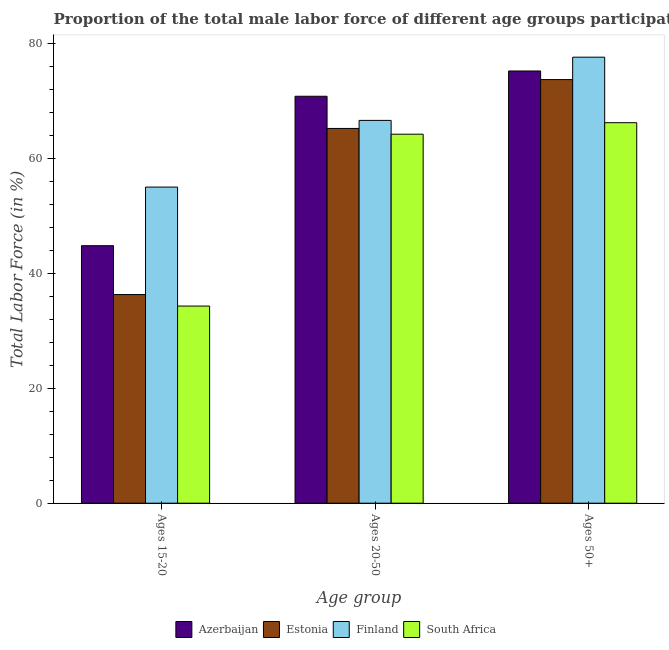How many different coloured bars are there?
Give a very brief answer. 4. How many groups of bars are there?
Make the answer very short. 3. Are the number of bars per tick equal to the number of legend labels?
Your response must be concise. Yes. Are the number of bars on each tick of the X-axis equal?
Keep it short and to the point. Yes. What is the label of the 2nd group of bars from the left?
Offer a terse response. Ages 20-50. What is the percentage of male labor force within the age group 15-20 in Azerbaijan?
Provide a short and direct response. 44.8. Across all countries, what is the maximum percentage of male labor force within the age group 15-20?
Provide a succinct answer. 55. Across all countries, what is the minimum percentage of male labor force above age 50?
Your answer should be very brief. 66.2. In which country was the percentage of male labor force within the age group 20-50 maximum?
Provide a short and direct response. Azerbaijan. In which country was the percentage of male labor force within the age group 20-50 minimum?
Your answer should be very brief. South Africa. What is the total percentage of male labor force within the age group 20-50 in the graph?
Keep it short and to the point. 266.8. What is the difference between the percentage of male labor force within the age group 15-20 in Azerbaijan and that in Estonia?
Give a very brief answer. 8.5. What is the difference between the percentage of male labor force within the age group 20-50 in Finland and the percentage of male labor force above age 50 in Estonia?
Your answer should be very brief. -7.1. What is the average percentage of male labor force within the age group 15-20 per country?
Your answer should be compact. 42.6. What is the difference between the percentage of male labor force within the age group 20-50 and percentage of male labor force within the age group 15-20 in South Africa?
Offer a very short reply. 29.9. In how many countries, is the percentage of male labor force within the age group 15-20 greater than 20 %?
Offer a terse response. 4. What is the ratio of the percentage of male labor force within the age group 20-50 in Estonia to that in South Africa?
Ensure brevity in your answer.  1.02. Is the percentage of male labor force within the age group 20-50 in Finland less than that in Azerbaijan?
Your response must be concise. Yes. What is the difference between the highest and the second highest percentage of male labor force above age 50?
Your response must be concise. 2.4. What is the difference between the highest and the lowest percentage of male labor force above age 50?
Your answer should be compact. 11.4. Is the sum of the percentage of male labor force within the age group 20-50 in Estonia and Azerbaijan greater than the maximum percentage of male labor force within the age group 15-20 across all countries?
Make the answer very short. Yes. What does the 3rd bar from the left in Ages 15-20 represents?
Your answer should be very brief. Finland. What does the 1st bar from the right in Ages 50+ represents?
Provide a short and direct response. South Africa. How many bars are there?
Give a very brief answer. 12. What is the difference between two consecutive major ticks on the Y-axis?
Provide a short and direct response. 20. Are the values on the major ticks of Y-axis written in scientific E-notation?
Provide a succinct answer. No. Does the graph contain grids?
Make the answer very short. No. How many legend labels are there?
Make the answer very short. 4. How are the legend labels stacked?
Keep it short and to the point. Horizontal. What is the title of the graph?
Your response must be concise. Proportion of the total male labor force of different age groups participating in production in 2002. Does "Azerbaijan" appear as one of the legend labels in the graph?
Keep it short and to the point. Yes. What is the label or title of the X-axis?
Your answer should be compact. Age group. What is the Total Labor Force (in %) of Azerbaijan in Ages 15-20?
Your answer should be compact. 44.8. What is the Total Labor Force (in %) in Estonia in Ages 15-20?
Your response must be concise. 36.3. What is the Total Labor Force (in %) of Finland in Ages 15-20?
Provide a short and direct response. 55. What is the Total Labor Force (in %) in South Africa in Ages 15-20?
Offer a terse response. 34.3. What is the Total Labor Force (in %) of Azerbaijan in Ages 20-50?
Give a very brief answer. 70.8. What is the Total Labor Force (in %) in Estonia in Ages 20-50?
Your answer should be compact. 65.2. What is the Total Labor Force (in %) in Finland in Ages 20-50?
Offer a terse response. 66.6. What is the Total Labor Force (in %) in South Africa in Ages 20-50?
Your answer should be compact. 64.2. What is the Total Labor Force (in %) in Azerbaijan in Ages 50+?
Make the answer very short. 75.2. What is the Total Labor Force (in %) of Estonia in Ages 50+?
Your response must be concise. 73.7. What is the Total Labor Force (in %) of Finland in Ages 50+?
Offer a terse response. 77.6. What is the Total Labor Force (in %) in South Africa in Ages 50+?
Ensure brevity in your answer.  66.2. Across all Age group, what is the maximum Total Labor Force (in %) of Azerbaijan?
Your answer should be compact. 75.2. Across all Age group, what is the maximum Total Labor Force (in %) in Estonia?
Offer a very short reply. 73.7. Across all Age group, what is the maximum Total Labor Force (in %) of Finland?
Provide a short and direct response. 77.6. Across all Age group, what is the maximum Total Labor Force (in %) in South Africa?
Offer a terse response. 66.2. Across all Age group, what is the minimum Total Labor Force (in %) in Azerbaijan?
Ensure brevity in your answer.  44.8. Across all Age group, what is the minimum Total Labor Force (in %) in Estonia?
Your answer should be very brief. 36.3. Across all Age group, what is the minimum Total Labor Force (in %) of Finland?
Your response must be concise. 55. Across all Age group, what is the minimum Total Labor Force (in %) in South Africa?
Your answer should be very brief. 34.3. What is the total Total Labor Force (in %) of Azerbaijan in the graph?
Your answer should be very brief. 190.8. What is the total Total Labor Force (in %) of Estonia in the graph?
Provide a succinct answer. 175.2. What is the total Total Labor Force (in %) in Finland in the graph?
Your answer should be very brief. 199.2. What is the total Total Labor Force (in %) of South Africa in the graph?
Keep it short and to the point. 164.7. What is the difference between the Total Labor Force (in %) of Azerbaijan in Ages 15-20 and that in Ages 20-50?
Your answer should be compact. -26. What is the difference between the Total Labor Force (in %) in Estonia in Ages 15-20 and that in Ages 20-50?
Provide a succinct answer. -28.9. What is the difference between the Total Labor Force (in %) in South Africa in Ages 15-20 and that in Ages 20-50?
Your answer should be very brief. -29.9. What is the difference between the Total Labor Force (in %) in Azerbaijan in Ages 15-20 and that in Ages 50+?
Offer a very short reply. -30.4. What is the difference between the Total Labor Force (in %) of Estonia in Ages 15-20 and that in Ages 50+?
Give a very brief answer. -37.4. What is the difference between the Total Labor Force (in %) of Finland in Ages 15-20 and that in Ages 50+?
Make the answer very short. -22.6. What is the difference between the Total Labor Force (in %) in South Africa in Ages 15-20 and that in Ages 50+?
Your answer should be compact. -31.9. What is the difference between the Total Labor Force (in %) of Azerbaijan in Ages 20-50 and that in Ages 50+?
Offer a terse response. -4.4. What is the difference between the Total Labor Force (in %) of Estonia in Ages 20-50 and that in Ages 50+?
Provide a short and direct response. -8.5. What is the difference between the Total Labor Force (in %) in Finland in Ages 20-50 and that in Ages 50+?
Your answer should be very brief. -11. What is the difference between the Total Labor Force (in %) in Azerbaijan in Ages 15-20 and the Total Labor Force (in %) in Estonia in Ages 20-50?
Your answer should be compact. -20.4. What is the difference between the Total Labor Force (in %) of Azerbaijan in Ages 15-20 and the Total Labor Force (in %) of Finland in Ages 20-50?
Your response must be concise. -21.8. What is the difference between the Total Labor Force (in %) in Azerbaijan in Ages 15-20 and the Total Labor Force (in %) in South Africa in Ages 20-50?
Give a very brief answer. -19.4. What is the difference between the Total Labor Force (in %) in Estonia in Ages 15-20 and the Total Labor Force (in %) in Finland in Ages 20-50?
Give a very brief answer. -30.3. What is the difference between the Total Labor Force (in %) in Estonia in Ages 15-20 and the Total Labor Force (in %) in South Africa in Ages 20-50?
Offer a very short reply. -27.9. What is the difference between the Total Labor Force (in %) of Finland in Ages 15-20 and the Total Labor Force (in %) of South Africa in Ages 20-50?
Ensure brevity in your answer.  -9.2. What is the difference between the Total Labor Force (in %) in Azerbaijan in Ages 15-20 and the Total Labor Force (in %) in Estonia in Ages 50+?
Offer a very short reply. -28.9. What is the difference between the Total Labor Force (in %) of Azerbaijan in Ages 15-20 and the Total Labor Force (in %) of Finland in Ages 50+?
Ensure brevity in your answer.  -32.8. What is the difference between the Total Labor Force (in %) of Azerbaijan in Ages 15-20 and the Total Labor Force (in %) of South Africa in Ages 50+?
Keep it short and to the point. -21.4. What is the difference between the Total Labor Force (in %) in Estonia in Ages 15-20 and the Total Labor Force (in %) in Finland in Ages 50+?
Make the answer very short. -41.3. What is the difference between the Total Labor Force (in %) of Estonia in Ages 15-20 and the Total Labor Force (in %) of South Africa in Ages 50+?
Make the answer very short. -29.9. What is the difference between the Total Labor Force (in %) in Finland in Ages 15-20 and the Total Labor Force (in %) in South Africa in Ages 50+?
Ensure brevity in your answer.  -11.2. What is the difference between the Total Labor Force (in %) in Azerbaijan in Ages 20-50 and the Total Labor Force (in %) in Estonia in Ages 50+?
Make the answer very short. -2.9. What is the difference between the Total Labor Force (in %) in Azerbaijan in Ages 20-50 and the Total Labor Force (in %) in Finland in Ages 50+?
Offer a very short reply. -6.8. What is the difference between the Total Labor Force (in %) in Azerbaijan in Ages 20-50 and the Total Labor Force (in %) in South Africa in Ages 50+?
Make the answer very short. 4.6. What is the difference between the Total Labor Force (in %) in Estonia in Ages 20-50 and the Total Labor Force (in %) in South Africa in Ages 50+?
Offer a terse response. -1. What is the average Total Labor Force (in %) in Azerbaijan per Age group?
Your answer should be very brief. 63.6. What is the average Total Labor Force (in %) in Estonia per Age group?
Your response must be concise. 58.4. What is the average Total Labor Force (in %) of Finland per Age group?
Give a very brief answer. 66.4. What is the average Total Labor Force (in %) in South Africa per Age group?
Offer a terse response. 54.9. What is the difference between the Total Labor Force (in %) of Azerbaijan and Total Labor Force (in %) of Finland in Ages 15-20?
Ensure brevity in your answer.  -10.2. What is the difference between the Total Labor Force (in %) of Estonia and Total Labor Force (in %) of Finland in Ages 15-20?
Your response must be concise. -18.7. What is the difference between the Total Labor Force (in %) of Estonia and Total Labor Force (in %) of South Africa in Ages 15-20?
Offer a terse response. 2. What is the difference between the Total Labor Force (in %) of Finland and Total Labor Force (in %) of South Africa in Ages 15-20?
Your answer should be compact. 20.7. What is the difference between the Total Labor Force (in %) of Azerbaijan and Total Labor Force (in %) of Estonia in Ages 20-50?
Offer a terse response. 5.6. What is the difference between the Total Labor Force (in %) in Azerbaijan and Total Labor Force (in %) in Finland in Ages 20-50?
Keep it short and to the point. 4.2. What is the difference between the Total Labor Force (in %) in Azerbaijan and Total Labor Force (in %) in South Africa in Ages 20-50?
Offer a terse response. 6.6. What is the difference between the Total Labor Force (in %) in Estonia and Total Labor Force (in %) in Finland in Ages 20-50?
Make the answer very short. -1.4. What is the difference between the Total Labor Force (in %) of Estonia and Total Labor Force (in %) of South Africa in Ages 20-50?
Your response must be concise. 1. What is the difference between the Total Labor Force (in %) of Azerbaijan and Total Labor Force (in %) of Finland in Ages 50+?
Give a very brief answer. -2.4. What is the difference between the Total Labor Force (in %) of Azerbaijan and Total Labor Force (in %) of South Africa in Ages 50+?
Offer a very short reply. 9. What is the difference between the Total Labor Force (in %) in Estonia and Total Labor Force (in %) in Finland in Ages 50+?
Ensure brevity in your answer.  -3.9. What is the ratio of the Total Labor Force (in %) in Azerbaijan in Ages 15-20 to that in Ages 20-50?
Offer a terse response. 0.63. What is the ratio of the Total Labor Force (in %) of Estonia in Ages 15-20 to that in Ages 20-50?
Your response must be concise. 0.56. What is the ratio of the Total Labor Force (in %) of Finland in Ages 15-20 to that in Ages 20-50?
Make the answer very short. 0.83. What is the ratio of the Total Labor Force (in %) in South Africa in Ages 15-20 to that in Ages 20-50?
Offer a terse response. 0.53. What is the ratio of the Total Labor Force (in %) in Azerbaijan in Ages 15-20 to that in Ages 50+?
Give a very brief answer. 0.6. What is the ratio of the Total Labor Force (in %) of Estonia in Ages 15-20 to that in Ages 50+?
Your response must be concise. 0.49. What is the ratio of the Total Labor Force (in %) of Finland in Ages 15-20 to that in Ages 50+?
Ensure brevity in your answer.  0.71. What is the ratio of the Total Labor Force (in %) of South Africa in Ages 15-20 to that in Ages 50+?
Give a very brief answer. 0.52. What is the ratio of the Total Labor Force (in %) of Azerbaijan in Ages 20-50 to that in Ages 50+?
Give a very brief answer. 0.94. What is the ratio of the Total Labor Force (in %) of Estonia in Ages 20-50 to that in Ages 50+?
Your answer should be compact. 0.88. What is the ratio of the Total Labor Force (in %) in Finland in Ages 20-50 to that in Ages 50+?
Ensure brevity in your answer.  0.86. What is the ratio of the Total Labor Force (in %) in South Africa in Ages 20-50 to that in Ages 50+?
Offer a terse response. 0.97. What is the difference between the highest and the second highest Total Labor Force (in %) in Azerbaijan?
Provide a short and direct response. 4.4. What is the difference between the highest and the second highest Total Labor Force (in %) in South Africa?
Ensure brevity in your answer.  2. What is the difference between the highest and the lowest Total Labor Force (in %) in Azerbaijan?
Give a very brief answer. 30.4. What is the difference between the highest and the lowest Total Labor Force (in %) in Estonia?
Give a very brief answer. 37.4. What is the difference between the highest and the lowest Total Labor Force (in %) in Finland?
Your answer should be very brief. 22.6. What is the difference between the highest and the lowest Total Labor Force (in %) of South Africa?
Your response must be concise. 31.9. 